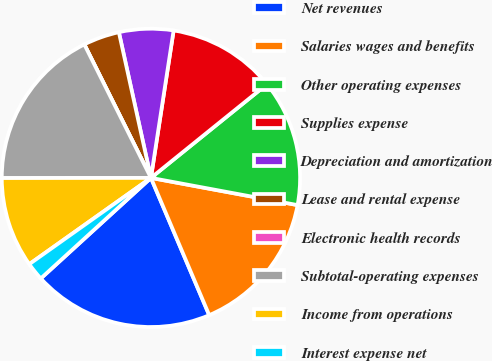Convert chart. <chart><loc_0><loc_0><loc_500><loc_500><pie_chart><fcel>Net revenues<fcel>Salaries wages and benefits<fcel>Other operating expenses<fcel>Supplies expense<fcel>Depreciation and amortization<fcel>Lease and rental expense<fcel>Electronic health records<fcel>Subtotal-operating expenses<fcel>Income from operations<fcel>Interest expense net<nl><fcel>19.61%<fcel>15.69%<fcel>13.73%<fcel>11.76%<fcel>5.88%<fcel>3.92%<fcel>0.0%<fcel>17.65%<fcel>9.8%<fcel>1.96%<nl></chart> 